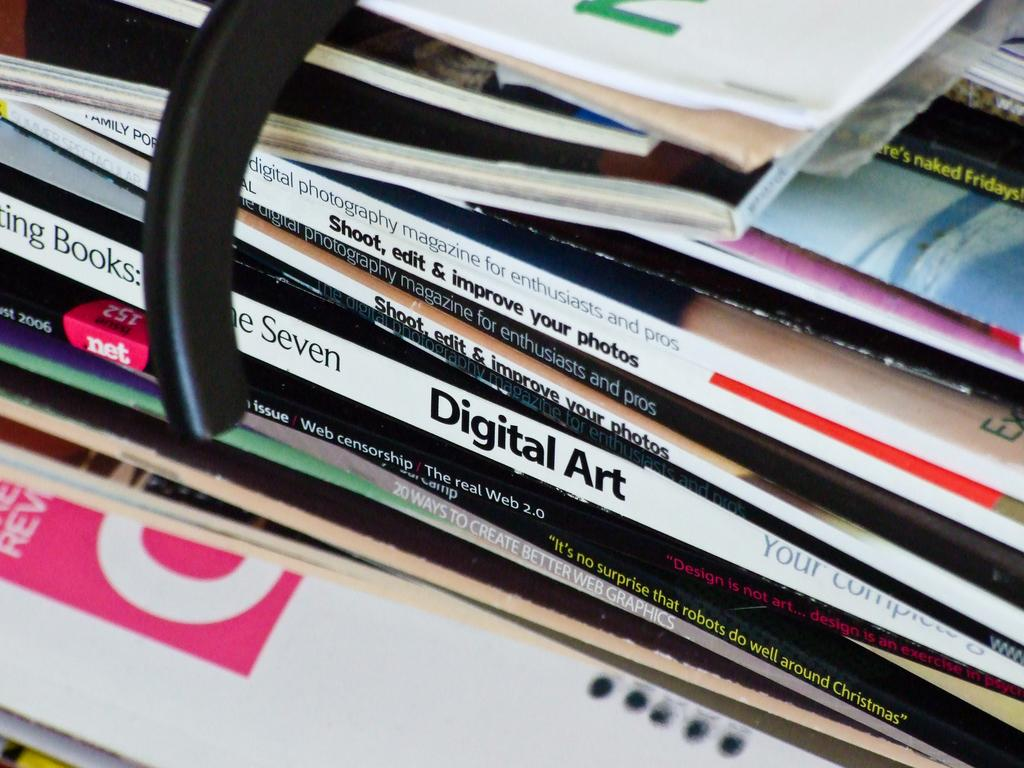<image>
Summarize the visual content of the image. A stack of books sitting on a desk with titles such as Digital Art and How to Improve your Photos. 